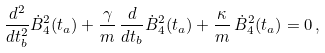Convert formula to latex. <formula><loc_0><loc_0><loc_500><loc_500>\frac { d ^ { 2 } } { d t _ { b } ^ { 2 } } { \dot { B } } ^ { 2 } _ { 4 } ( t _ { a } ) + \frac { \gamma } { m } \, \frac { d } { d t _ { b } } { \dot { B } } ^ { 2 } _ { 4 } ( t _ { a } ) + \frac { \kappa } { m } \, { \dot { B } } ^ { 2 } _ { 4 } ( t _ { a } ) = 0 \, ,</formula> 